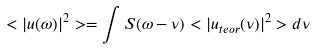Convert formula to latex. <formula><loc_0><loc_0><loc_500><loc_500>< | u ( \omega ) | ^ { 2 } > = \int S ( \omega - \nu ) < | u _ { t e o r } ( \nu ) | ^ { 2 } > d \nu</formula> 